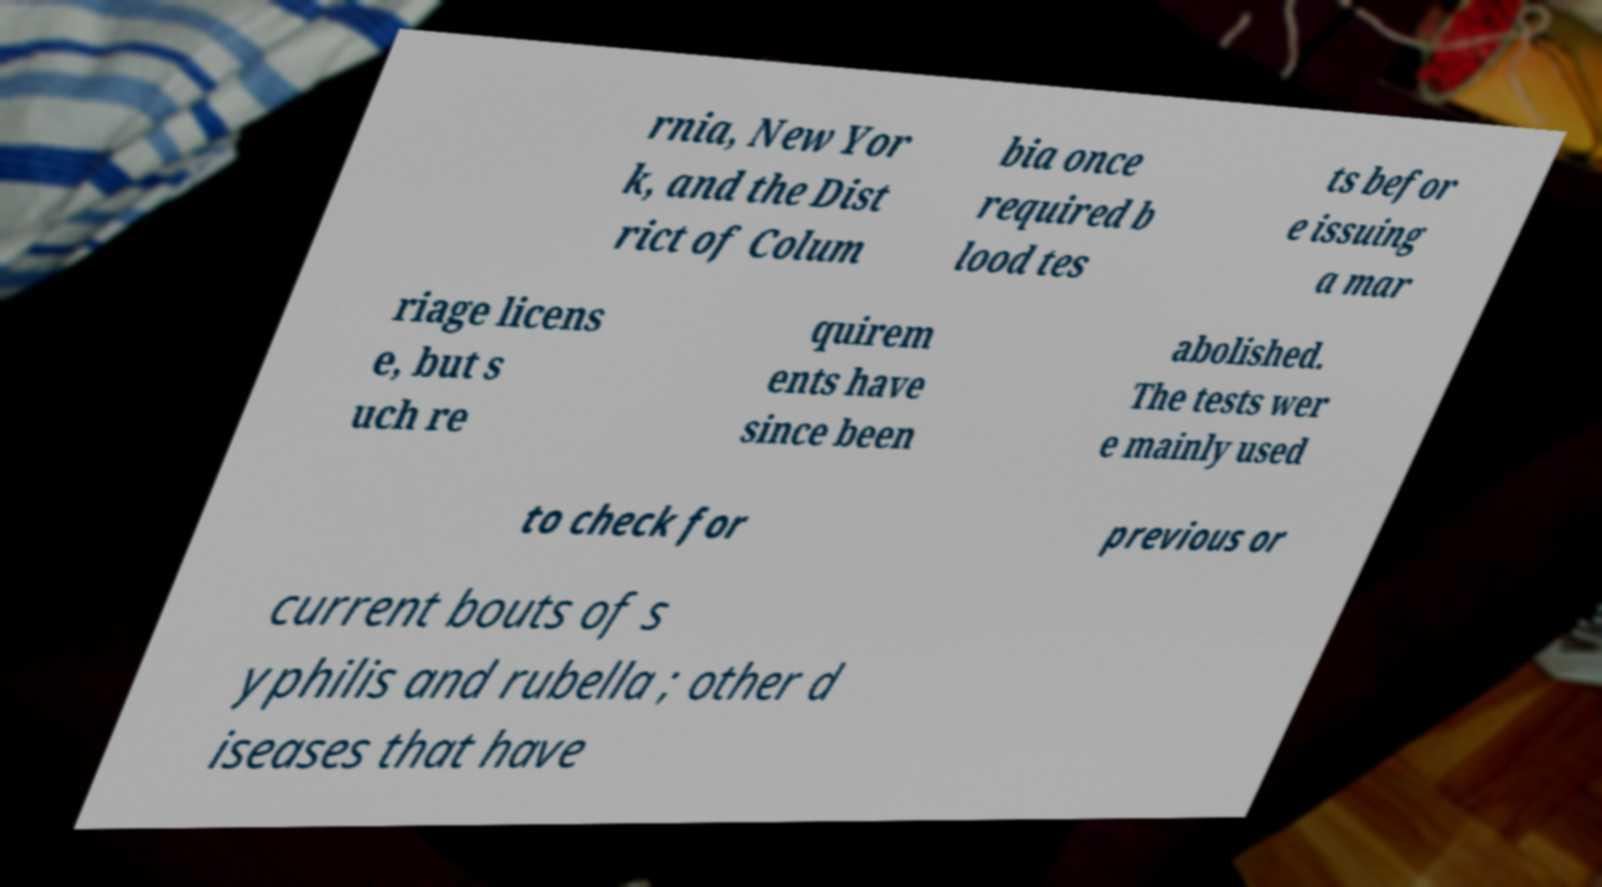I need the written content from this picture converted into text. Can you do that? rnia, New Yor k, and the Dist rict of Colum bia once required b lood tes ts befor e issuing a mar riage licens e, but s uch re quirem ents have since been abolished. The tests wer e mainly used to check for previous or current bouts of s yphilis and rubella ; other d iseases that have 